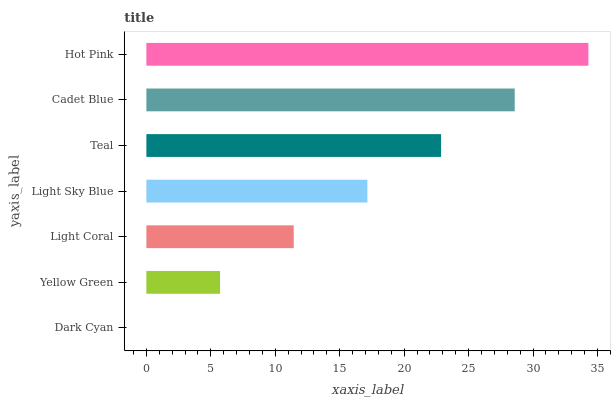Is Dark Cyan the minimum?
Answer yes or no. Yes. Is Hot Pink the maximum?
Answer yes or no. Yes. Is Yellow Green the minimum?
Answer yes or no. No. Is Yellow Green the maximum?
Answer yes or no. No. Is Yellow Green greater than Dark Cyan?
Answer yes or no. Yes. Is Dark Cyan less than Yellow Green?
Answer yes or no. Yes. Is Dark Cyan greater than Yellow Green?
Answer yes or no. No. Is Yellow Green less than Dark Cyan?
Answer yes or no. No. Is Light Sky Blue the high median?
Answer yes or no. Yes. Is Light Sky Blue the low median?
Answer yes or no. Yes. Is Light Coral the high median?
Answer yes or no. No. Is Hot Pink the low median?
Answer yes or no. No. 